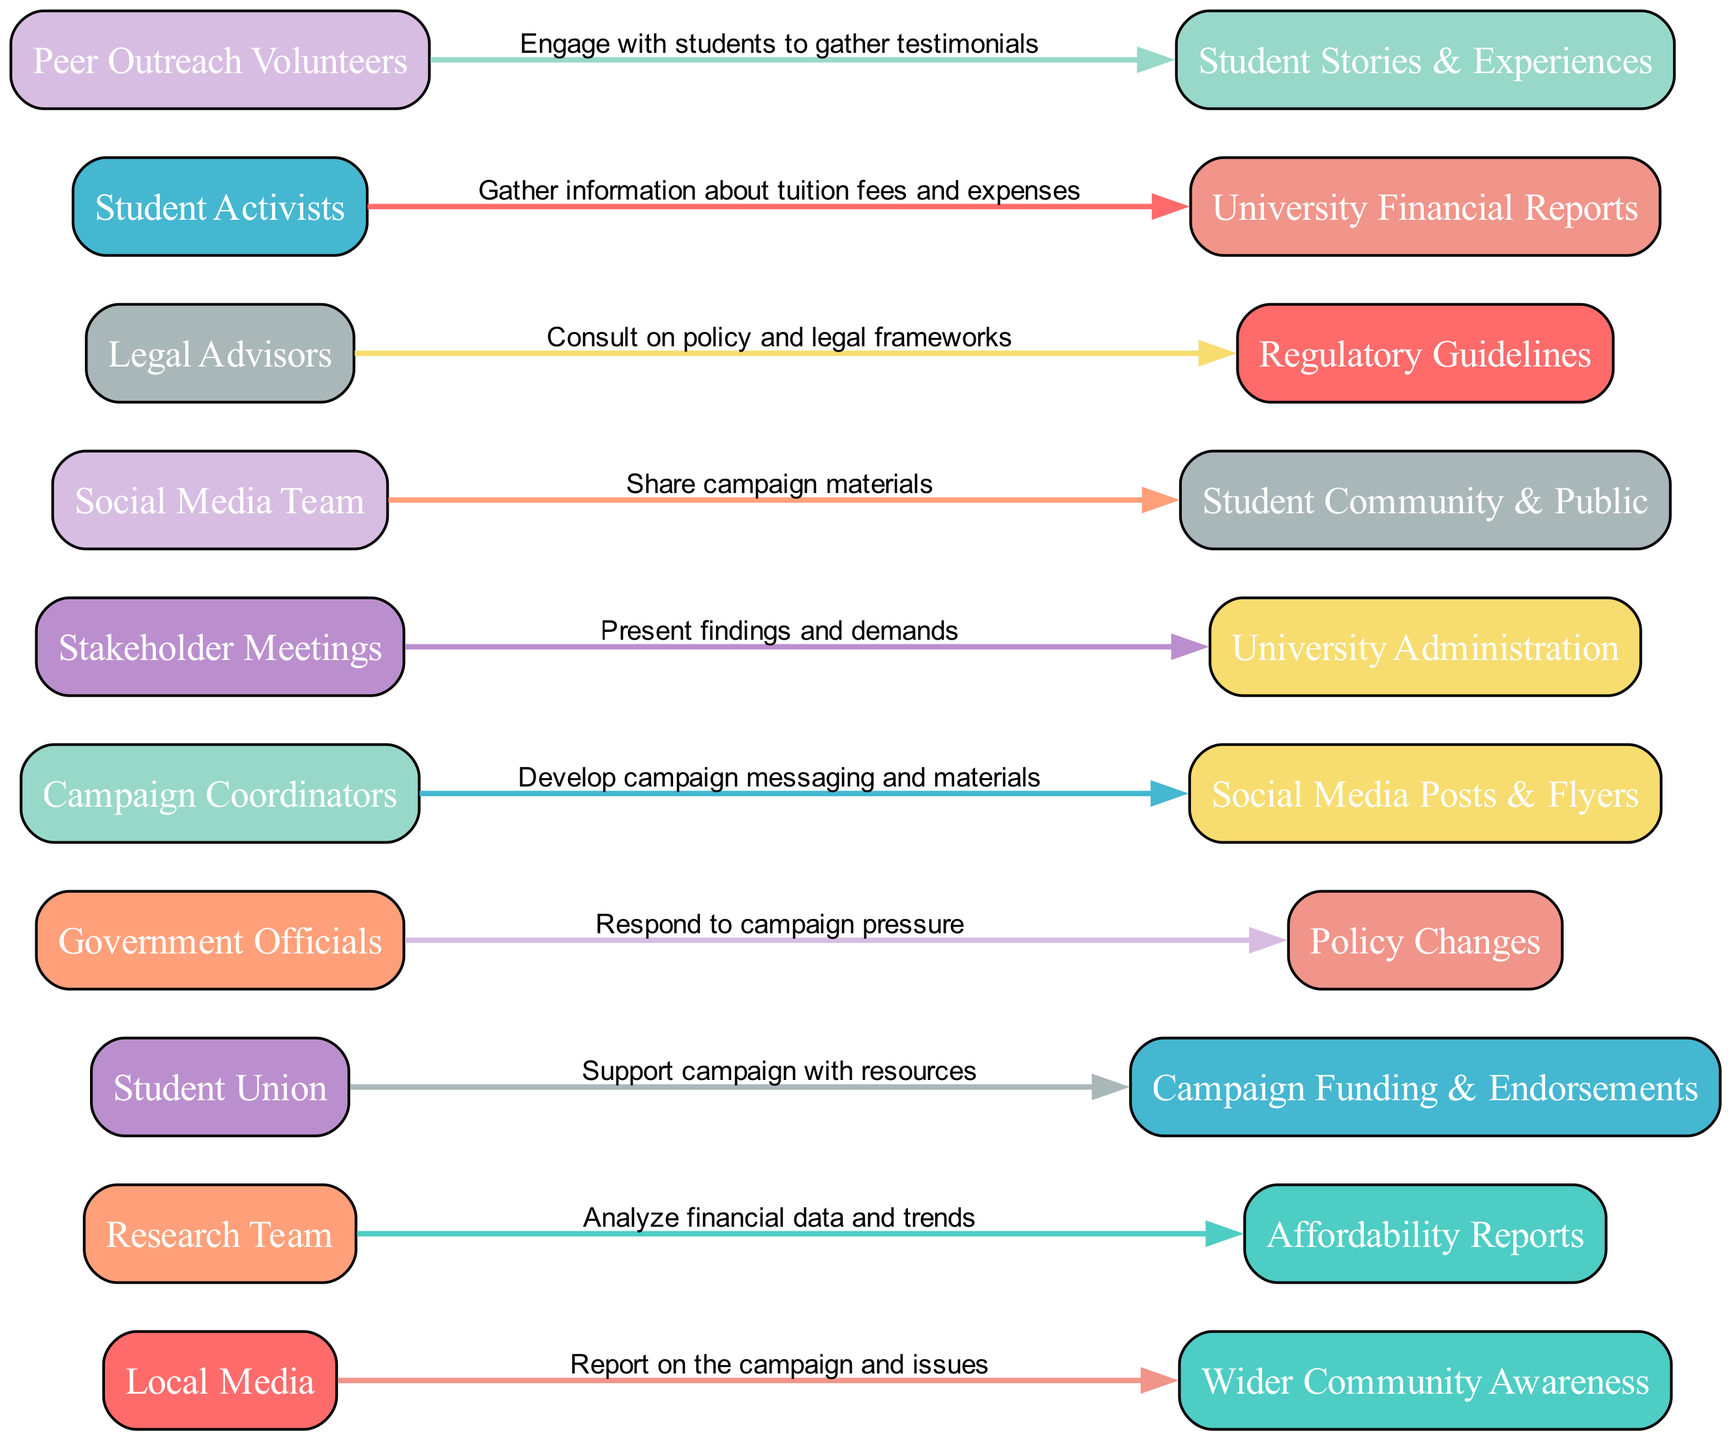What actors are involved in the campaign? The diagram includes the actors "Student Activists," "Research Team," "Campaign Coordinators," "Social Media Team," "Peer Outreach Volunteers," "Legal Advisors," "Stakeholder Meetings," "Local Media," "Student Union," and "Government Officials." Each actor is listed as a node connected to various targets through actions.
Answer: Student Activists, Research Team, Campaign Coordinators, Social Media Team, Peer Outreach Volunteers, Legal Advisors, Stakeholder Meetings, Local Media, Student Union, Government Officials How many total actions are represented in the diagram? The diagram has 10 unique actions, with each action represented as an edge connecting an actor to a target. By counting the edges in the visual flow of the diagram, we confirm this number.
Answer: 10 Which actor is responsible for gathering testimonials? The "Peer Outreach Volunteers" are responsible for gathering testimonials, indicated by the action directly linking them to "Student Stories & Experiences." This can be identified by following the connection from the "Peer Outreach Volunteers" node.
Answer: Peer Outreach Volunteers What does the "Student Union" support the campaign with? The "Student Union" supports the campaign with "Campaign Funding & Endorsements," clearly indicated as the target connected to the "Student Union" node through the corresponding action.
Answer: Campaign Funding & Endorsements What is the primary target of the "Social Media Team"? The primary target of the "Social Media Team" is the "Student Community & Public," as it is the endpoint connected directly to this actor through their action of sharing campaign materials.
Answer: Student Community & Public What is the role of "Legal Advisors"? "Legal Advisors" consult on policy and legal frameworks, as their action is linked to the target of "Regulatory Guidelines." This is indicated in the diagram by the edge drawn from the "Legal Advisors" node to this respective target.
Answer: Consult on policy and legal frameworks How do "Government Officials" respond to the campaign? "Government Officials" respond to the campaign pressure by enacting "Policy Changes," which is evident from the directed edge connecting them to this specific target. By tracing the flow from "Government Officials," we reach this conclusion.
Answer: Policy Changes What information is analyzed by the "Research Team"? The "Research Team" analyzes "financial data and trends," as denoted by the action linked to the "Affordability Reports." This connection allows us to identify what the research is focused on.
Answer: Financial data and trends Which external entity covers the campaign in the media? The "Local Media" covers the campaign, and their action of reporting is directed towards creating "Wider Community Awareness," as shown in their connection in the diagram.
Answer: Wider Community Awareness 